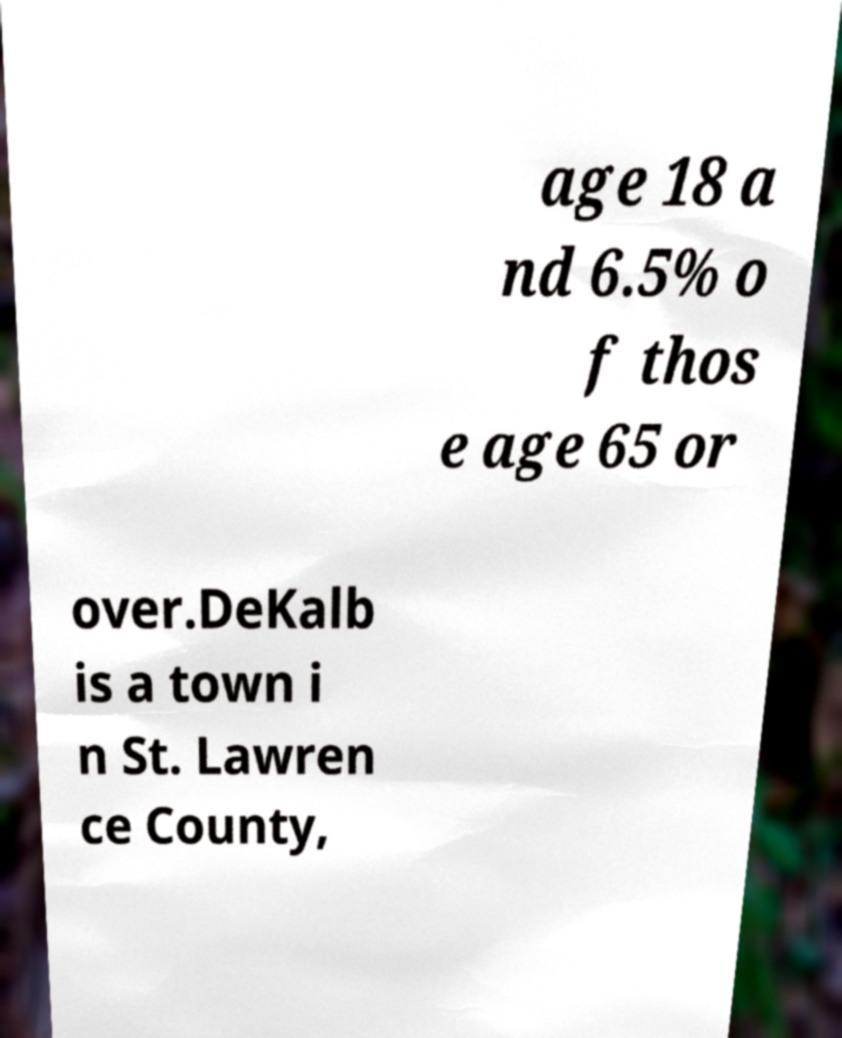Can you accurately transcribe the text from the provided image for me? age 18 a nd 6.5% o f thos e age 65 or over.DeKalb is a town i n St. Lawren ce County, 